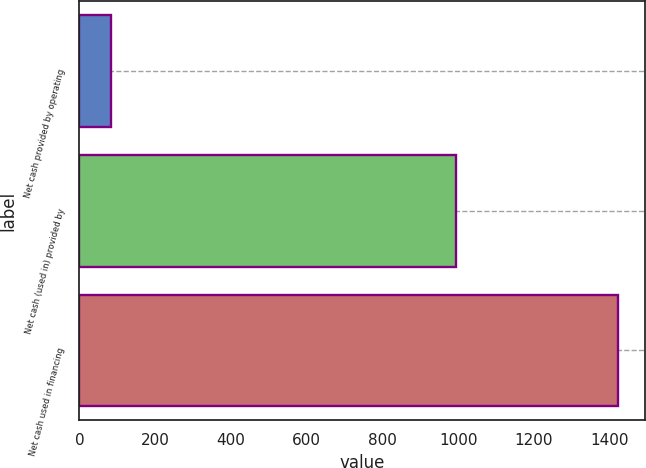Convert chart to OTSL. <chart><loc_0><loc_0><loc_500><loc_500><bar_chart><fcel>Net cash provided by operating<fcel>Net cash (used in) provided by<fcel>Net cash used in financing<nl><fcel>82.5<fcel>995<fcel>1422.5<nl></chart> 